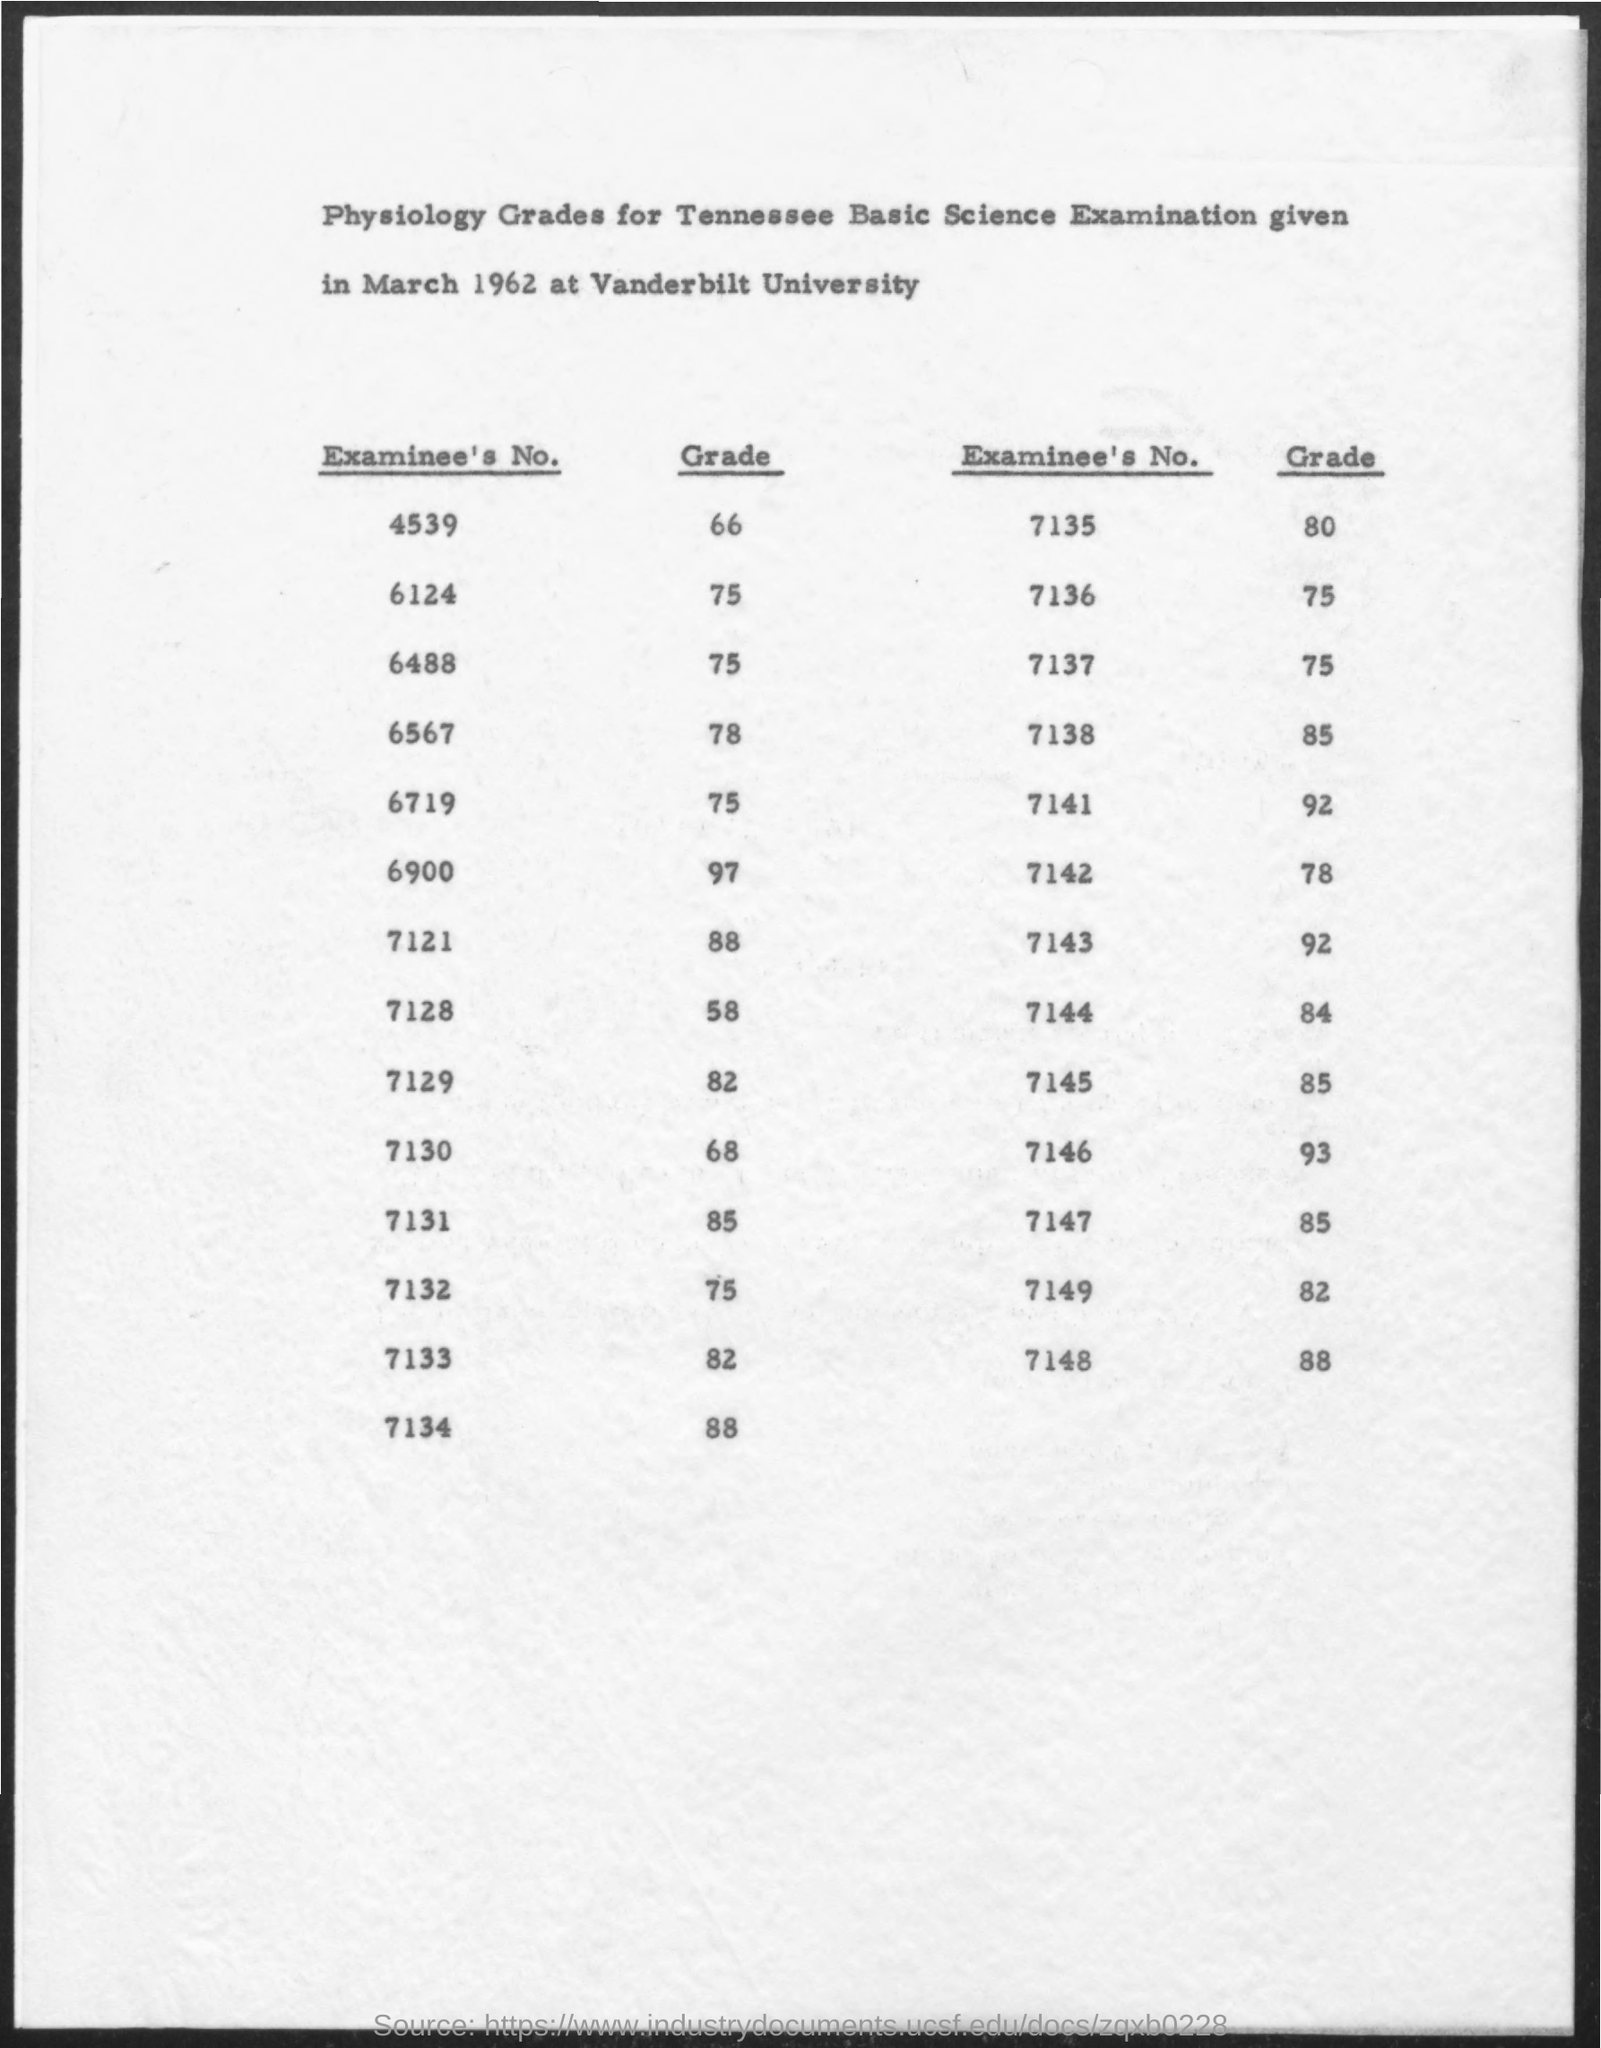What is the name of the university mentioned in the given form ?
Your response must be concise. Vanderbilt university. What is the grade for the examinee's no. 4539 ?
Offer a terse response. 66. What is the grade for the examinee's no. 6124 ?
Offer a very short reply. 75. What is the grade for the examinee's no. 6567 ?
Keep it short and to the point. 78. What is the grade for the examinee's no. 7138 ?
Your answer should be very brief. 85. What is the grade for the examinee's no.7121 ?
Ensure brevity in your answer.  88. What is the grade for the examinee's no. 7143 ?
Your answer should be compact. 92. What is the grade for the examinee's no. 7141 ?
Ensure brevity in your answer.  92. What is the grade for the examinee's no. 7132 ?
Offer a very short reply. 75. What is the grade for the examinee's no. 7148 ?
Make the answer very short. 88. 